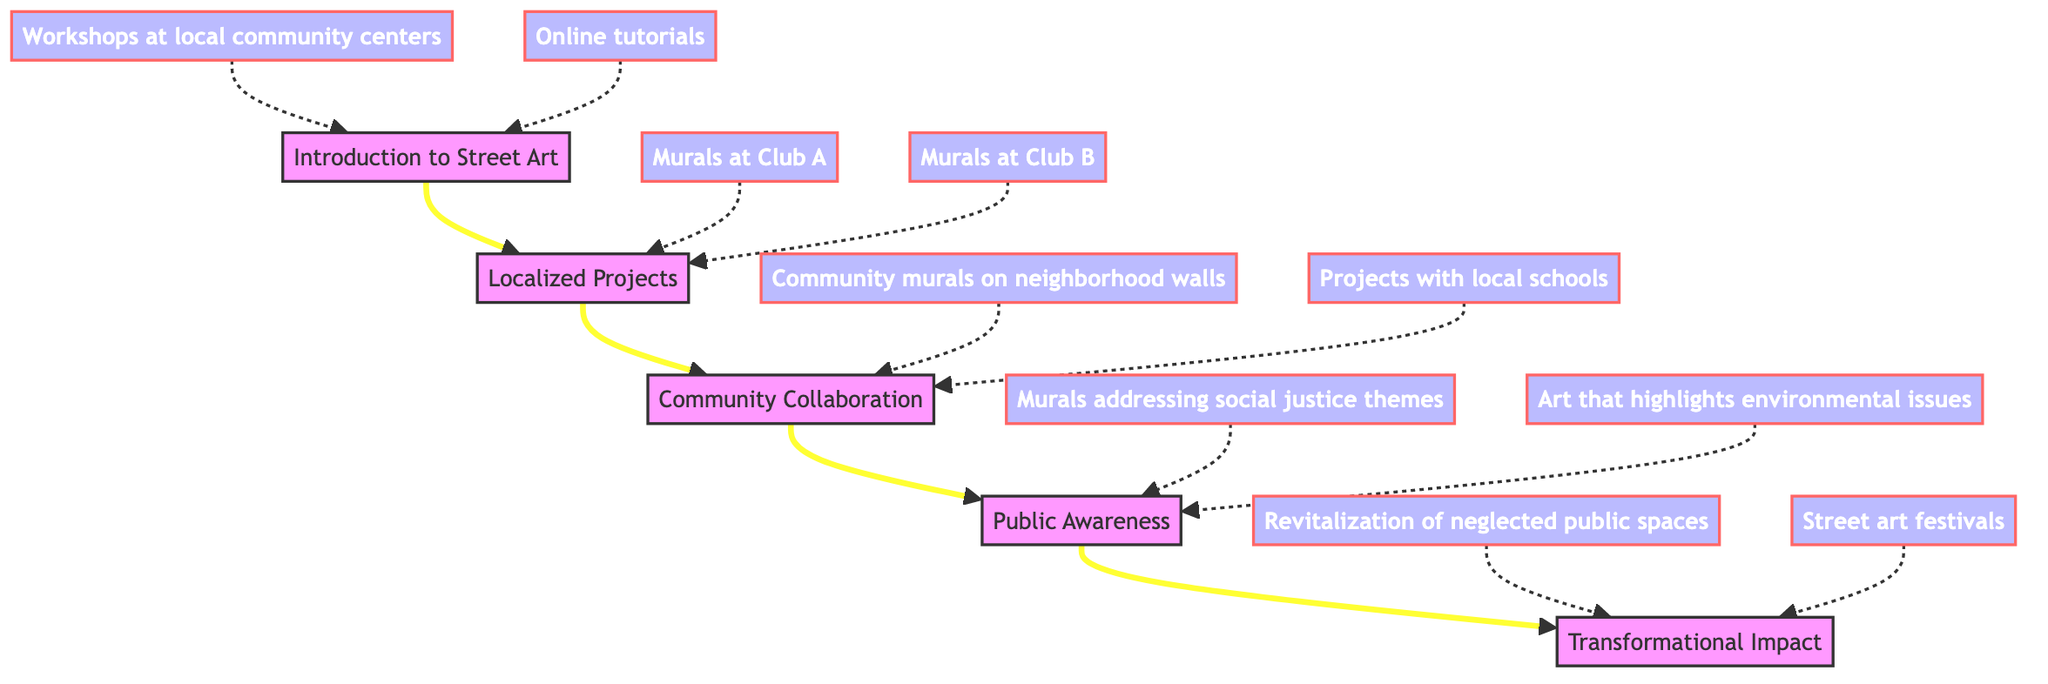What is the highest level in the flow chart? The highest level in the flow chart is identified at the top, labeled as "Transformational Impact." This is the final node that the flow leading up from the lower levels converges upon.
Answer: Transformational Impact How many levels are there in the flow chart? Counting each distinct level from bottom to top, there are five levels present. These levels are: Introduction to Street Art, Localized Projects, Community Collaboration, Public Awareness, and Transformational Impact.
Answer: 5 Which level follows Localized Projects? From the flow chart, it can be seen that the level directly following "Localized Projects" is "Community Collaboration." This is confirmed by the connecting arrow that points from B to C.
Answer: Community Collaboration What type of projects are included under Public Awareness? The examples provided under "Public Awareness" include "Murals addressing social justice themes" and "Art that highlights environmental issues." This indicates that the projects focus on raising awareness about these particular issues.
Answer: Murals addressing social justice themes, Art that highlights environmental issues Which level is the starting point of the flow chart? The starting point of the flow chart is at the bottom, which is "Introduction to Street Art." This is where the flow begins and the arrows point upward towards the subsequent levels.
Answer: Introduction to Street Art How does Localized Projects impact Community Collaboration? "Localized Projects" directly influences "Community Collaboration" as indicated by the connecting arrow. This suggests that projects such as murals encourage greater community involvement and participation in broader art initiatives.
Answer: Engages community participation What is the relationship between Community Collaboration and Transformational Impact? "Community Collaboration" is a step that leads directly to "Transformational Impact," indicating that engaging the community helps to bring about meaningful changes in the community spaces through art.
Answer: Essential step for change What are the examples of the first level? The first level "Introduction to Street Art" includes examples such as "Workshops at local community centers" and "Online tutorials." These are the foundational activities mentioned that introduce individuals to street art.
Answer: Workshops at local community centers, Online tutorials What effect does Transformational Impact have on the community? "Transformational Impact" leads to tangible changes in community spaces and perceptions, showing a direct link to revitalization and arts events as both integral parts of transforming public areas.
Answer: Revitalization of community spaces, Street art festivals 